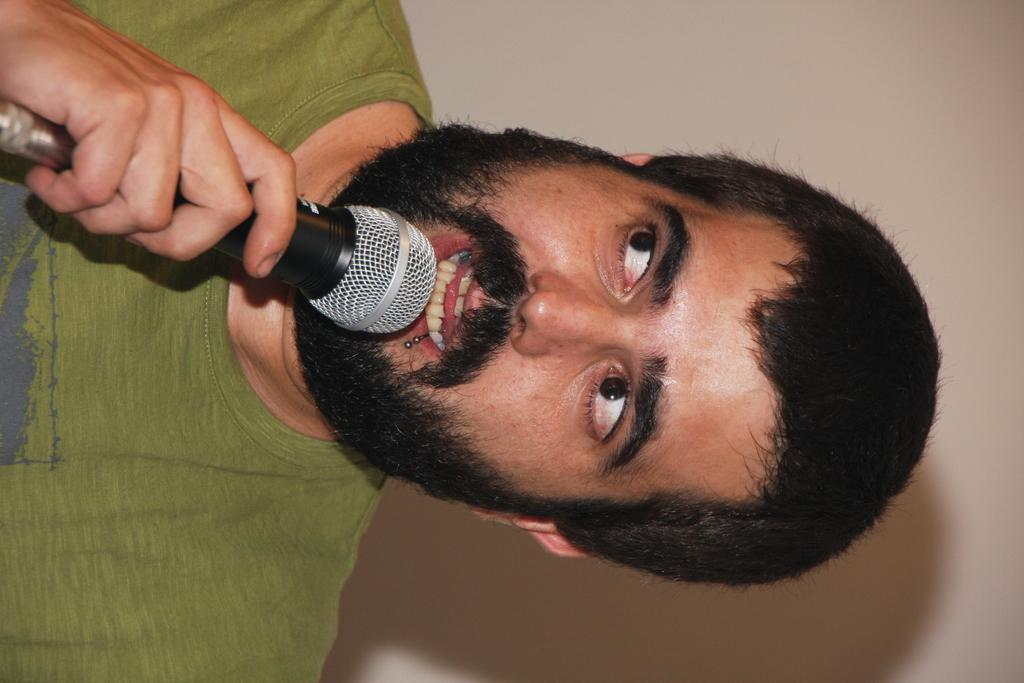What is the main subject of the image? There is a man in the image. What is the man doing in the image? The man is standing and holding a black microphone. What is the man doing with the microphone? The man is speaking into the microphone. What can be seen in the background of the image? There is a white wall in the background of the image. Can you see a trail of skate marks behind the man in the image? There is no trail of skate marks visible in the image. 